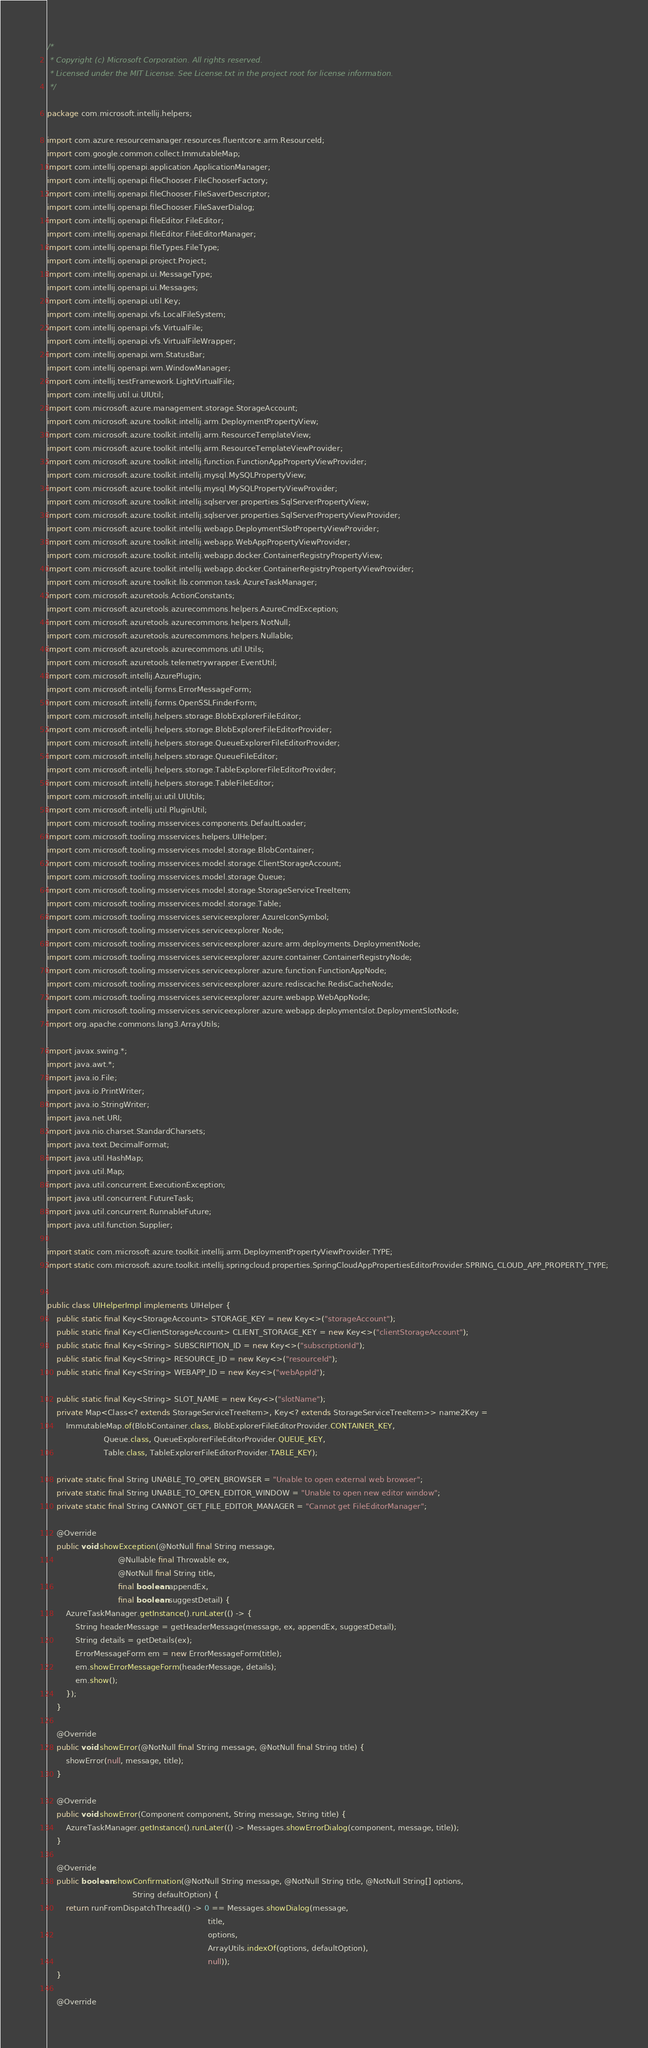<code> <loc_0><loc_0><loc_500><loc_500><_Java_>/*
 * Copyright (c) Microsoft Corporation. All rights reserved.
 * Licensed under the MIT License. See License.txt in the project root for license information.
 */

package com.microsoft.intellij.helpers;

import com.azure.resourcemanager.resources.fluentcore.arm.ResourceId;
import com.google.common.collect.ImmutableMap;
import com.intellij.openapi.application.ApplicationManager;
import com.intellij.openapi.fileChooser.FileChooserFactory;
import com.intellij.openapi.fileChooser.FileSaverDescriptor;
import com.intellij.openapi.fileChooser.FileSaverDialog;
import com.intellij.openapi.fileEditor.FileEditor;
import com.intellij.openapi.fileEditor.FileEditorManager;
import com.intellij.openapi.fileTypes.FileType;
import com.intellij.openapi.project.Project;
import com.intellij.openapi.ui.MessageType;
import com.intellij.openapi.ui.Messages;
import com.intellij.openapi.util.Key;
import com.intellij.openapi.vfs.LocalFileSystem;
import com.intellij.openapi.vfs.VirtualFile;
import com.intellij.openapi.vfs.VirtualFileWrapper;
import com.intellij.openapi.wm.StatusBar;
import com.intellij.openapi.wm.WindowManager;
import com.intellij.testFramework.LightVirtualFile;
import com.intellij.util.ui.UIUtil;
import com.microsoft.azure.management.storage.StorageAccount;
import com.microsoft.azure.toolkit.intellij.arm.DeploymentPropertyView;
import com.microsoft.azure.toolkit.intellij.arm.ResourceTemplateView;
import com.microsoft.azure.toolkit.intellij.arm.ResourceTemplateViewProvider;
import com.microsoft.azure.toolkit.intellij.function.FunctionAppPropertyViewProvider;
import com.microsoft.azure.toolkit.intellij.mysql.MySQLPropertyView;
import com.microsoft.azure.toolkit.intellij.mysql.MySQLPropertyViewProvider;
import com.microsoft.azure.toolkit.intellij.sqlserver.properties.SqlServerPropertyView;
import com.microsoft.azure.toolkit.intellij.sqlserver.properties.SqlServerPropertyViewProvider;
import com.microsoft.azure.toolkit.intellij.webapp.DeploymentSlotPropertyViewProvider;
import com.microsoft.azure.toolkit.intellij.webapp.WebAppPropertyViewProvider;
import com.microsoft.azure.toolkit.intellij.webapp.docker.ContainerRegistryPropertyView;
import com.microsoft.azure.toolkit.intellij.webapp.docker.ContainerRegistryPropertyViewProvider;
import com.microsoft.azure.toolkit.lib.common.task.AzureTaskManager;
import com.microsoft.azuretools.ActionConstants;
import com.microsoft.azuretools.azurecommons.helpers.AzureCmdException;
import com.microsoft.azuretools.azurecommons.helpers.NotNull;
import com.microsoft.azuretools.azurecommons.helpers.Nullable;
import com.microsoft.azuretools.azurecommons.util.Utils;
import com.microsoft.azuretools.telemetrywrapper.EventUtil;
import com.microsoft.intellij.AzurePlugin;
import com.microsoft.intellij.forms.ErrorMessageForm;
import com.microsoft.intellij.forms.OpenSSLFinderForm;
import com.microsoft.intellij.helpers.storage.BlobExplorerFileEditor;
import com.microsoft.intellij.helpers.storage.BlobExplorerFileEditorProvider;
import com.microsoft.intellij.helpers.storage.QueueExplorerFileEditorProvider;
import com.microsoft.intellij.helpers.storage.QueueFileEditor;
import com.microsoft.intellij.helpers.storage.TableExplorerFileEditorProvider;
import com.microsoft.intellij.helpers.storage.TableFileEditor;
import com.microsoft.intellij.ui.util.UIUtils;
import com.microsoft.intellij.util.PluginUtil;
import com.microsoft.tooling.msservices.components.DefaultLoader;
import com.microsoft.tooling.msservices.helpers.UIHelper;
import com.microsoft.tooling.msservices.model.storage.BlobContainer;
import com.microsoft.tooling.msservices.model.storage.ClientStorageAccount;
import com.microsoft.tooling.msservices.model.storage.Queue;
import com.microsoft.tooling.msservices.model.storage.StorageServiceTreeItem;
import com.microsoft.tooling.msservices.model.storage.Table;
import com.microsoft.tooling.msservices.serviceexplorer.AzureIconSymbol;
import com.microsoft.tooling.msservices.serviceexplorer.Node;
import com.microsoft.tooling.msservices.serviceexplorer.azure.arm.deployments.DeploymentNode;
import com.microsoft.tooling.msservices.serviceexplorer.azure.container.ContainerRegistryNode;
import com.microsoft.tooling.msservices.serviceexplorer.azure.function.FunctionAppNode;
import com.microsoft.tooling.msservices.serviceexplorer.azure.rediscache.RedisCacheNode;
import com.microsoft.tooling.msservices.serviceexplorer.azure.webapp.WebAppNode;
import com.microsoft.tooling.msservices.serviceexplorer.azure.webapp.deploymentslot.DeploymentSlotNode;
import org.apache.commons.lang3.ArrayUtils;

import javax.swing.*;
import java.awt.*;
import java.io.File;
import java.io.PrintWriter;
import java.io.StringWriter;
import java.net.URI;
import java.nio.charset.StandardCharsets;
import java.text.DecimalFormat;
import java.util.HashMap;
import java.util.Map;
import java.util.concurrent.ExecutionException;
import java.util.concurrent.FutureTask;
import java.util.concurrent.RunnableFuture;
import java.util.function.Supplier;

import static com.microsoft.azure.toolkit.intellij.arm.DeploymentPropertyViewProvider.TYPE;
import static com.microsoft.azure.toolkit.intellij.springcloud.properties.SpringCloudAppPropertiesEditorProvider.SPRING_CLOUD_APP_PROPERTY_TYPE;


public class UIHelperImpl implements UIHelper {
    public static final Key<StorageAccount> STORAGE_KEY = new Key<>("storageAccount");
    public static final Key<ClientStorageAccount> CLIENT_STORAGE_KEY = new Key<>("clientStorageAccount");
    public static final Key<String> SUBSCRIPTION_ID = new Key<>("subscriptionId");
    public static final Key<String> RESOURCE_ID = new Key<>("resourceId");
    public static final Key<String> WEBAPP_ID = new Key<>("webAppId");

    public static final Key<String> SLOT_NAME = new Key<>("slotName");
    private Map<Class<? extends StorageServiceTreeItem>, Key<? extends StorageServiceTreeItem>> name2Key =
        ImmutableMap.of(BlobContainer.class, BlobExplorerFileEditorProvider.CONTAINER_KEY,
                        Queue.class, QueueExplorerFileEditorProvider.QUEUE_KEY,
                        Table.class, TableExplorerFileEditorProvider.TABLE_KEY);

    private static final String UNABLE_TO_OPEN_BROWSER = "Unable to open external web browser";
    private static final String UNABLE_TO_OPEN_EDITOR_WINDOW = "Unable to open new editor window";
    private static final String CANNOT_GET_FILE_EDITOR_MANAGER = "Cannot get FileEditorManager";

    @Override
    public void showException(@NotNull final String message,
                              @Nullable final Throwable ex,
                              @NotNull final String title,
                              final boolean appendEx,
                              final boolean suggestDetail) {
        AzureTaskManager.getInstance().runLater(() -> {
            String headerMessage = getHeaderMessage(message, ex, appendEx, suggestDetail);
            String details = getDetails(ex);
            ErrorMessageForm em = new ErrorMessageForm(title);
            em.showErrorMessageForm(headerMessage, details);
            em.show();
        });
    }

    @Override
    public void showError(@NotNull final String message, @NotNull final String title) {
        showError(null, message, title);
    }

    @Override
    public void showError(Component component, String message, String title) {
        AzureTaskManager.getInstance().runLater(() -> Messages.showErrorDialog(component, message, title));
    }

    @Override
    public boolean showConfirmation(@NotNull String message, @NotNull String title, @NotNull String[] options,
                                    String defaultOption) {
        return runFromDispatchThread(() -> 0 == Messages.showDialog(message,
                                                                    title,
                                                                    options,
                                                                    ArrayUtils.indexOf(options, defaultOption),
                                                                    null));
    }

    @Override</code> 